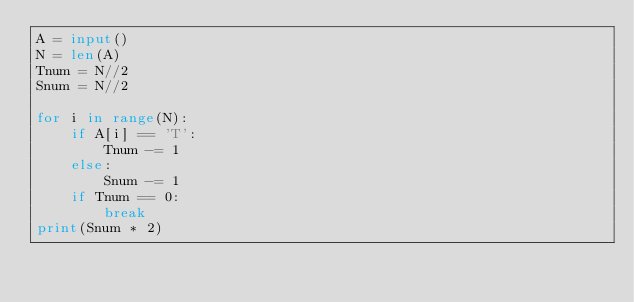<code> <loc_0><loc_0><loc_500><loc_500><_Python_>A = input()
N = len(A)
Tnum = N//2
Snum = N//2

for i in range(N):
    if A[i] == 'T':
        Tnum -= 1
    else:
        Snum -= 1
    if Tnum == 0:
        break
print(Snum * 2)

</code> 